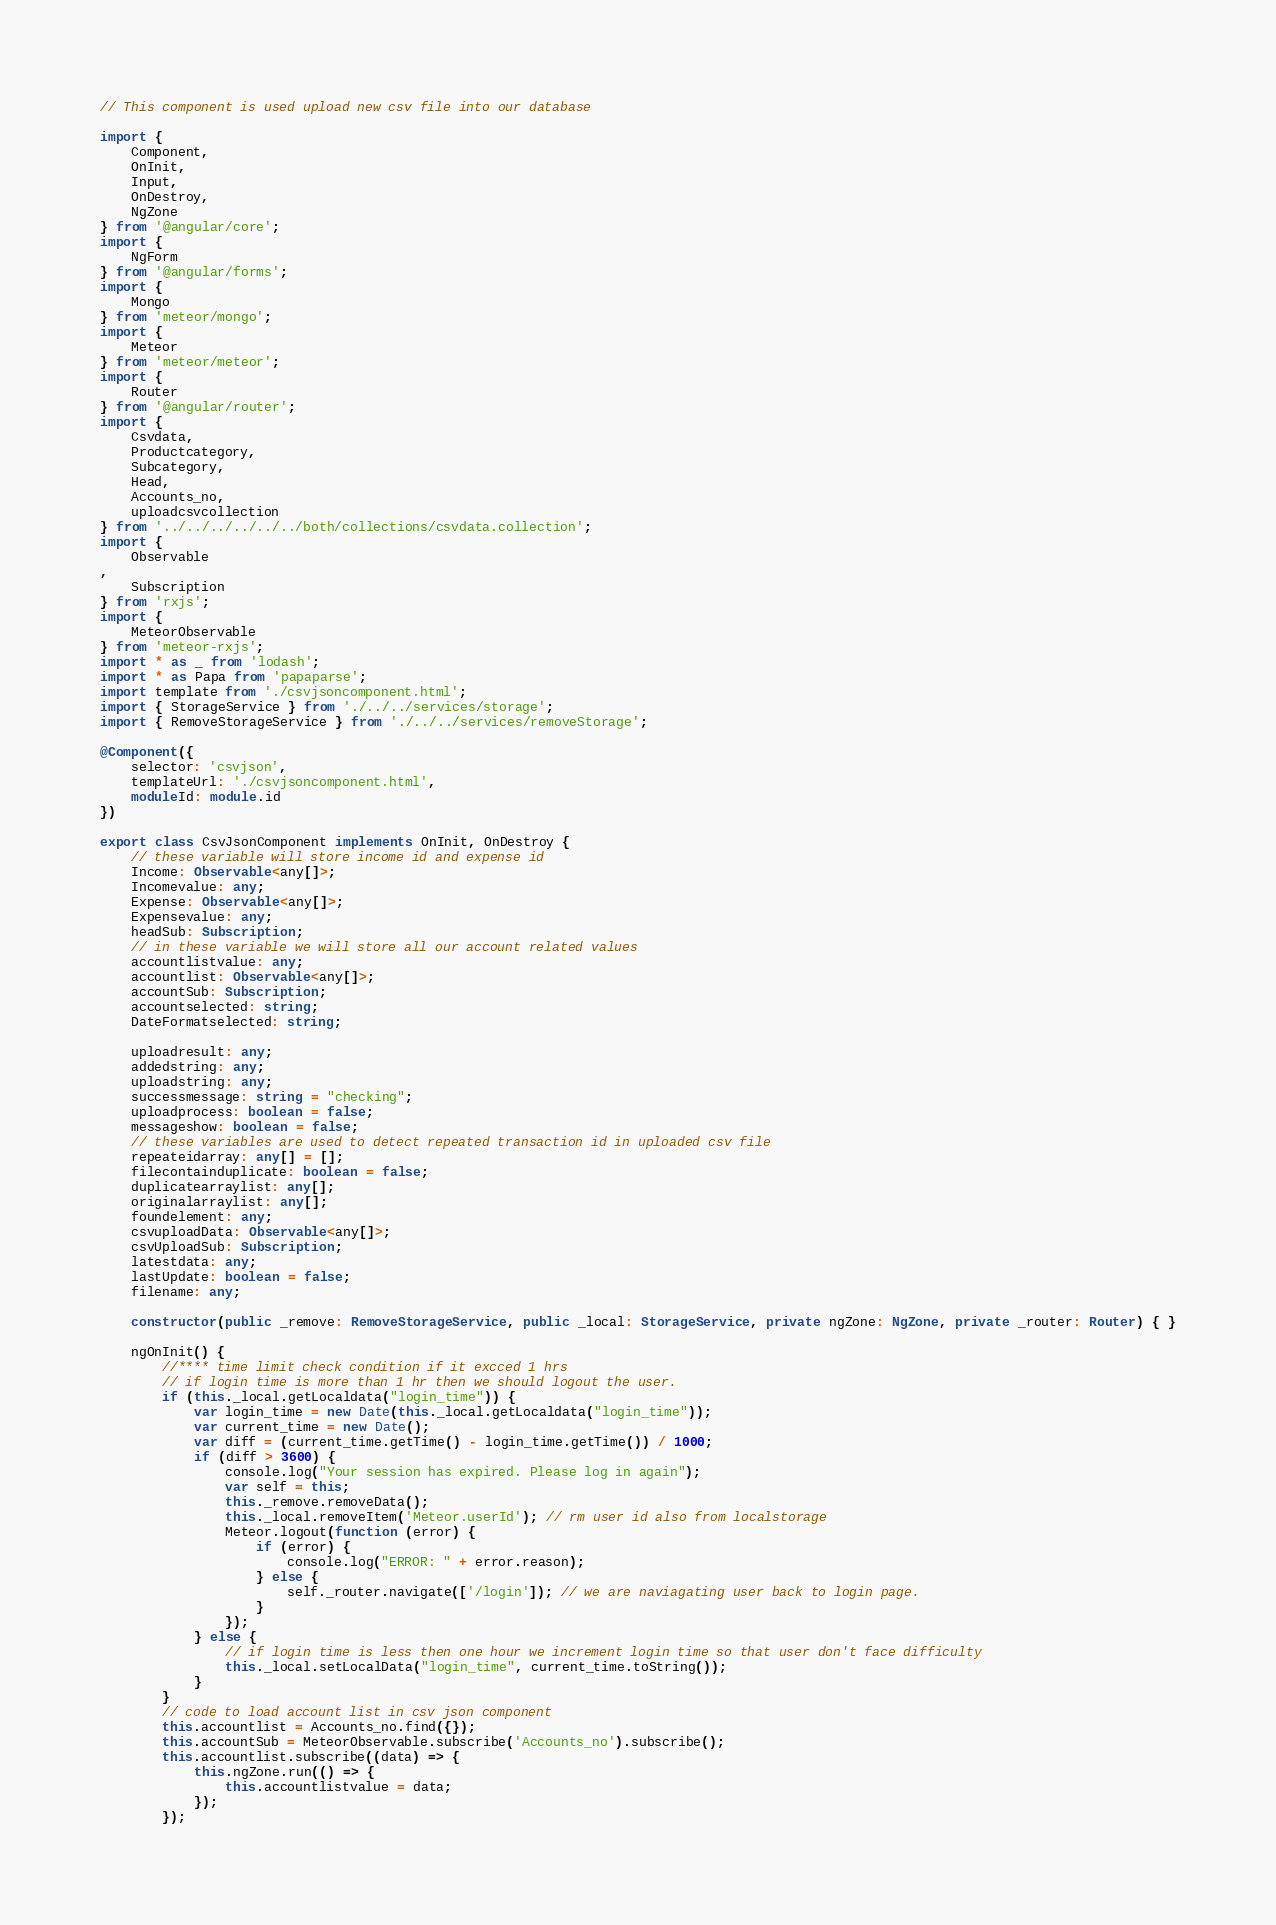<code> <loc_0><loc_0><loc_500><loc_500><_TypeScript_>// This component is used upload new csv file into our database

import {
    Component,
    OnInit,
    Input,
    OnDestroy,
    NgZone
} from '@angular/core';
import {
    NgForm
} from '@angular/forms';
import {
    Mongo
} from 'meteor/mongo';
import {
    Meteor
} from 'meteor/meteor';
import {
    Router
} from '@angular/router';
import {
    Csvdata,
    Productcategory,
    Subcategory,
    Head,
    Accounts_no,
    uploadcsvcollection
} from '../../../../../../both/collections/csvdata.collection';
import {
    Observable
, 
    Subscription
} from 'rxjs';
import {
    MeteorObservable
} from 'meteor-rxjs';
import * as _ from 'lodash';
import * as Papa from 'papaparse';
import template from './csvjsoncomponent.html';
import { StorageService } from './../../services/storage';
import { RemoveStorageService } from './../../services/removeStorage';

@Component({
    selector: 'csvjson',
    templateUrl: './csvjsoncomponent.html',
    moduleId: module.id
})

export class CsvJsonComponent implements OnInit, OnDestroy {
    // these variable will store income id and expense id
    Income: Observable<any[]>;
    Incomevalue: any;
    Expense: Observable<any[]>;
    Expensevalue: any;
    headSub: Subscription;
    // in these variable we will store all our account related values
    accountlistvalue: any;
    accountlist: Observable<any[]>;
    accountSub: Subscription;
    accountselected: string;
    DateFormatselected: string;

    uploadresult: any;
    addedstring: any;
    uploadstring: any;
    successmessage: string = "checking";
    uploadprocess: boolean = false;
    messageshow: boolean = false;
    // these variables are used to detect repeated transaction id in uploaded csv file
    repeateidarray: any[] = [];
    filecontainduplicate: boolean = false;
    duplicatearraylist: any[];
    originalarraylist: any[];
    foundelement: any;
    csvuploadData: Observable<any[]>;
    csvUploadSub: Subscription;
    latestdata: any;
    lastUpdate: boolean = false;
    filename: any;

    constructor(public _remove: RemoveStorageService, public _local: StorageService, private ngZone: NgZone, private _router: Router) { }

    ngOnInit() {
        //**** time limit check condition if it excced 1 hrs
        // if login time is more than 1 hr then we should logout the user.
        if (this._local.getLocaldata("login_time")) {
            var login_time = new Date(this._local.getLocaldata("login_time"));
            var current_time = new Date();
            var diff = (current_time.getTime() - login_time.getTime()) / 1000;
            if (diff > 3600) {
                console.log("Your session has expired. Please log in again");
                var self = this;
                this._remove.removeData();
                this._local.removeItem('Meteor.userId'); // rm user id also from localstorage
                Meteor.logout(function (error) {
                    if (error) {
                        console.log("ERROR: " + error.reason);
                    } else {
                        self._router.navigate(['/login']); // we are naviagating user back to login page.
                    }
                });
            } else {
                // if login time is less then one hour we increment login time so that user don't face difficulty
                this._local.setLocalData("login_time", current_time.toString());
            }
        }
        // code to load account list in csv json component
        this.accountlist = Accounts_no.find({});
        this.accountSub = MeteorObservable.subscribe('Accounts_no').subscribe();
        this.accountlist.subscribe((data) => {
            this.ngZone.run(() => {
                this.accountlistvalue = data;
            });
        });
</code> 